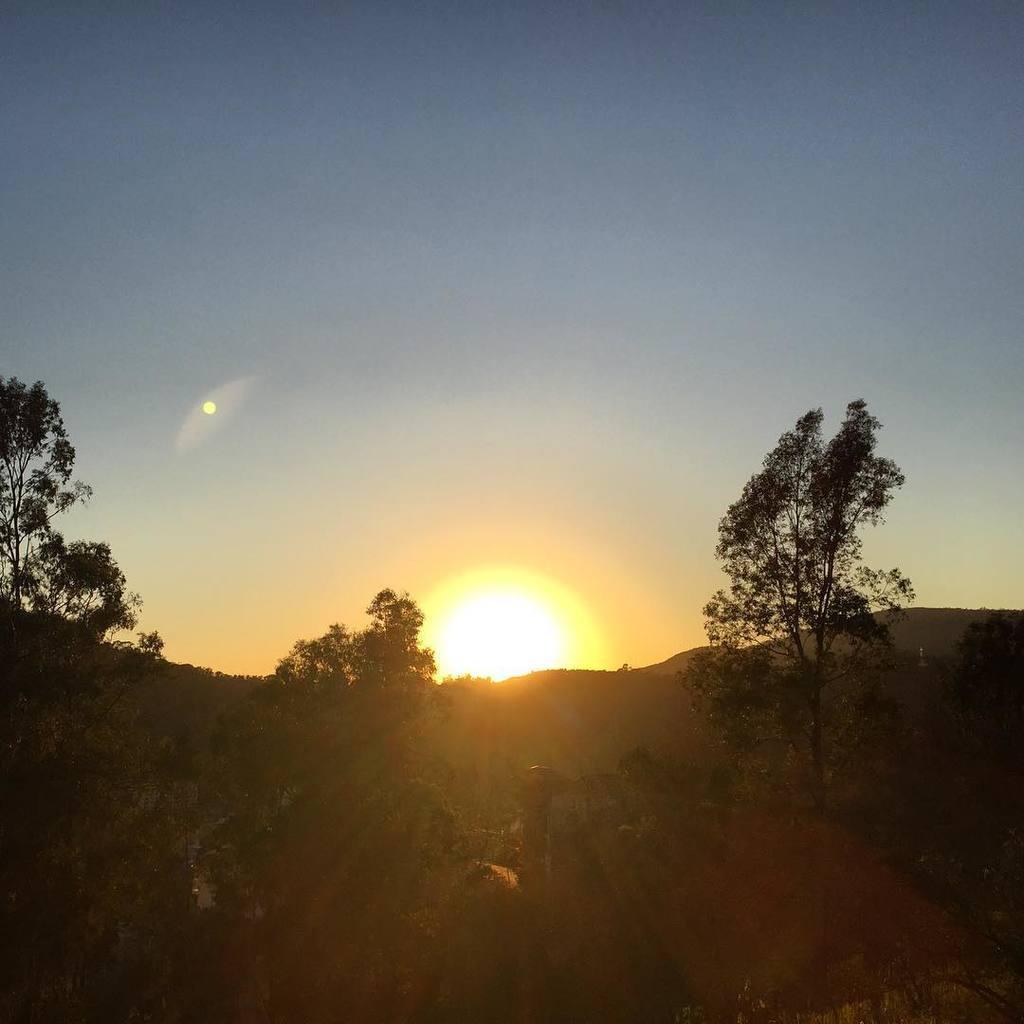How would you summarize this image in a sentence or two? In this image we can see trees, mountains and sunset in the sky. 